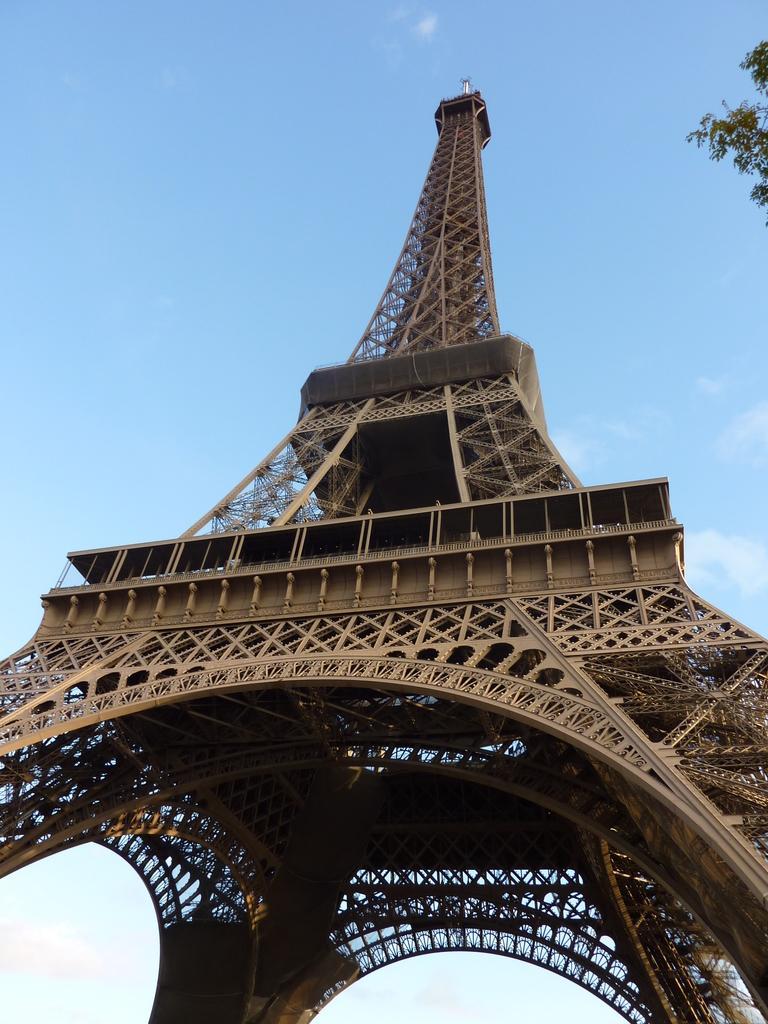Could you give a brief overview of what you see in this image? In the image there is a tower and on the right side there is a tree visible and above its sky. 